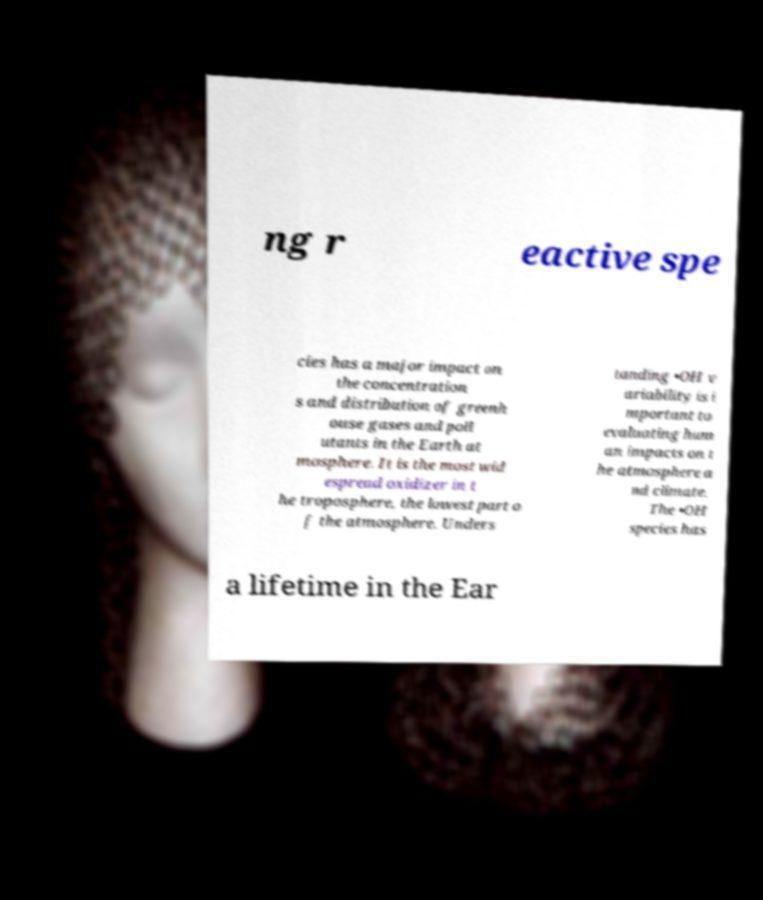What messages or text are displayed in this image? I need them in a readable, typed format. ng r eactive spe cies has a major impact on the concentration s and distribution of greenh ouse gases and poll utants in the Earth at mosphere. It is the most wid espread oxidizer in t he troposphere, the lowest part o f the atmosphere. Unders tanding •OH v ariability is i mportant to evaluating hum an impacts on t he atmosphere a nd climate. The •OH species has a lifetime in the Ear 